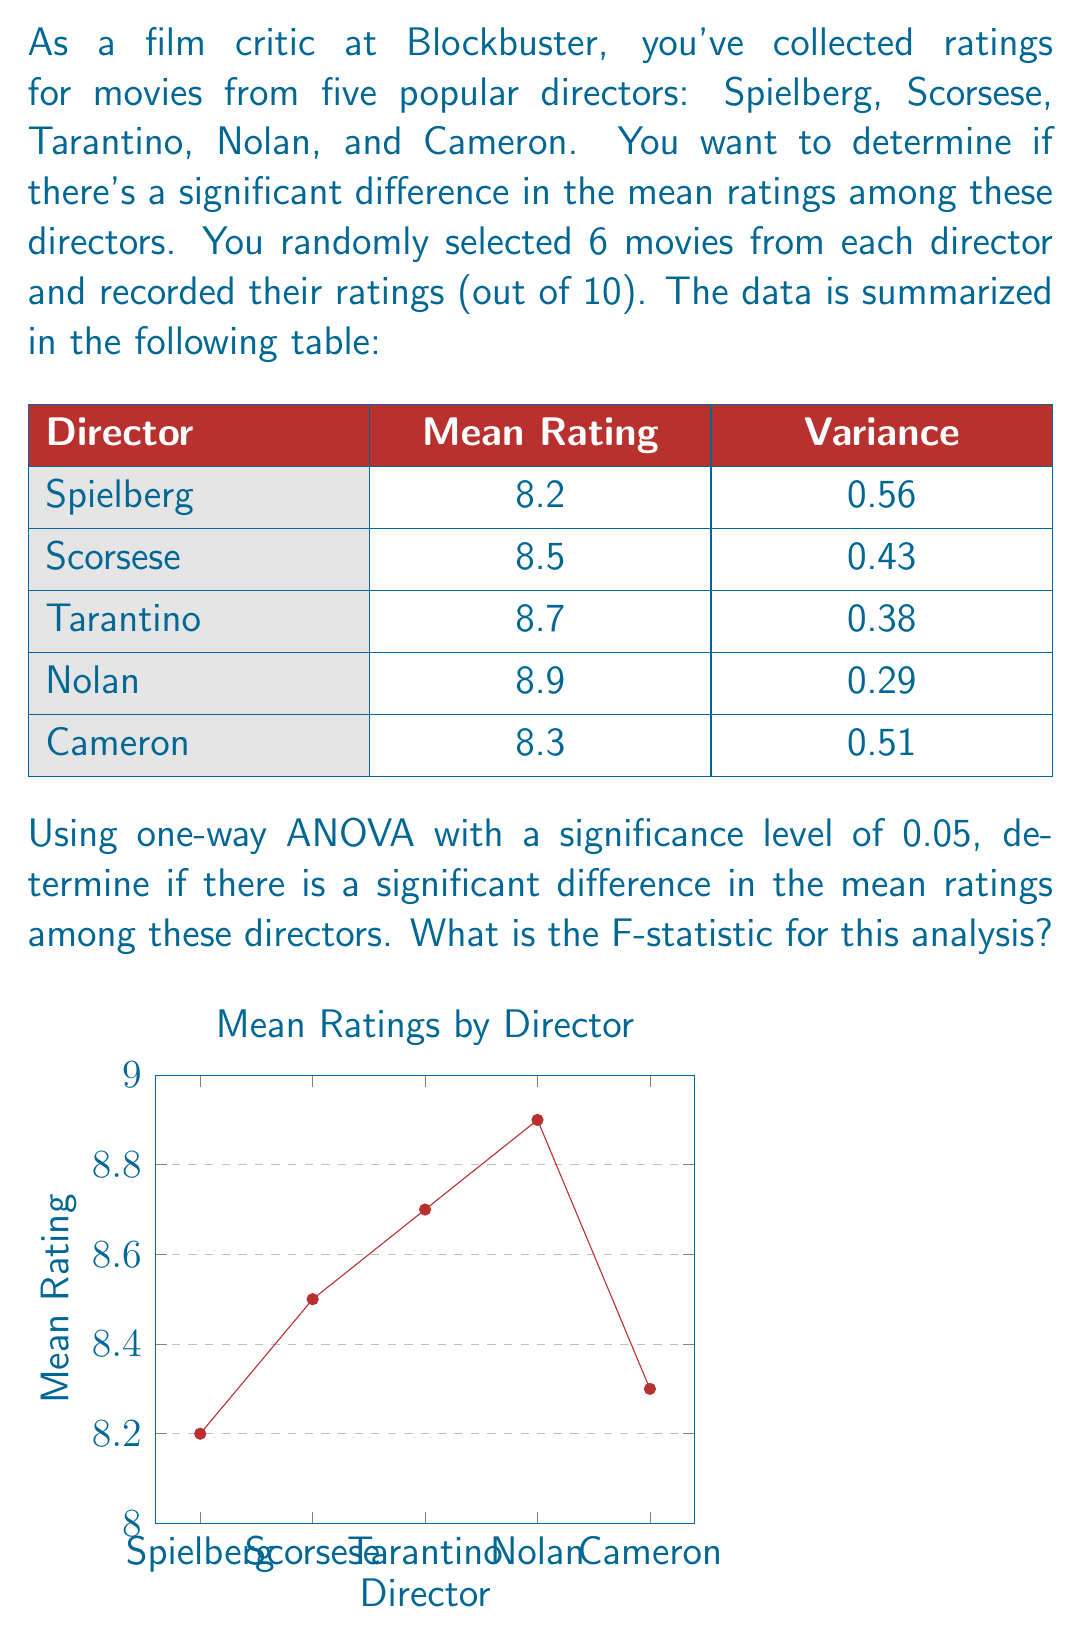What is the answer to this math problem? To solve this problem using one-way ANOVA, we need to follow these steps:

1. Calculate the grand mean:
   $\bar{X} = \frac{8.2 + 8.5 + 8.7 + 8.9 + 8.3}{5} = 8.52$

2. Calculate the Sum of Squares Between (SSB):
   $$SSB = \sum_{i=1}^{k} n_i(\bar{X_i} - \bar{X})^2$$
   where $k$ is the number of groups (5), $n_i$ is the number of samples in each group (6), $\bar{X_i}$ is the mean of each group, and $\bar{X}$ is the grand mean.
   
   $$SSB = 6[(8.2 - 8.52)^2 + (8.5 - 8.52)^2 + (8.7 - 8.52)^2 + (8.9 - 8.52)^2 + (8.3 - 8.52)^2]$$
   $$SSB = 6[0.1024 + 0.0004 + 0.0324 + 0.1444 + 0.0484] = 1.968$$

3. Calculate the Sum of Squares Within (SSW):
   $$SSW = \sum_{i=1}^{k} (n_i - 1)s_i^2$$
   where $s_i^2$ is the variance of each group.
   
   $$SSW = 5(0.56 + 0.43 + 0.38 + 0.29 + 0.51) = 10.85$$

4. Calculate the degrees of freedom:
   $df_{between} = k - 1 = 5 - 1 = 4$
   $df_{within} = N - k = 30 - 5 = 25$ (where N is the total number of samples)

5. Calculate the Mean Square Between (MSB) and Mean Square Within (MSW):
   $$MSB = \frac{SSB}{df_{between}} = \frac{1.968}{4} = 0.492$$
   $$MSW = \frac{SSW}{df_{within}} = \frac{10.85}{25} = 0.434$$

6. Calculate the F-statistic:
   $$F = \frac{MSB}{MSW} = \frac{0.492}{0.434} = 1.134$$

The F-statistic for this analysis is 1.134.
Answer: 1.134 